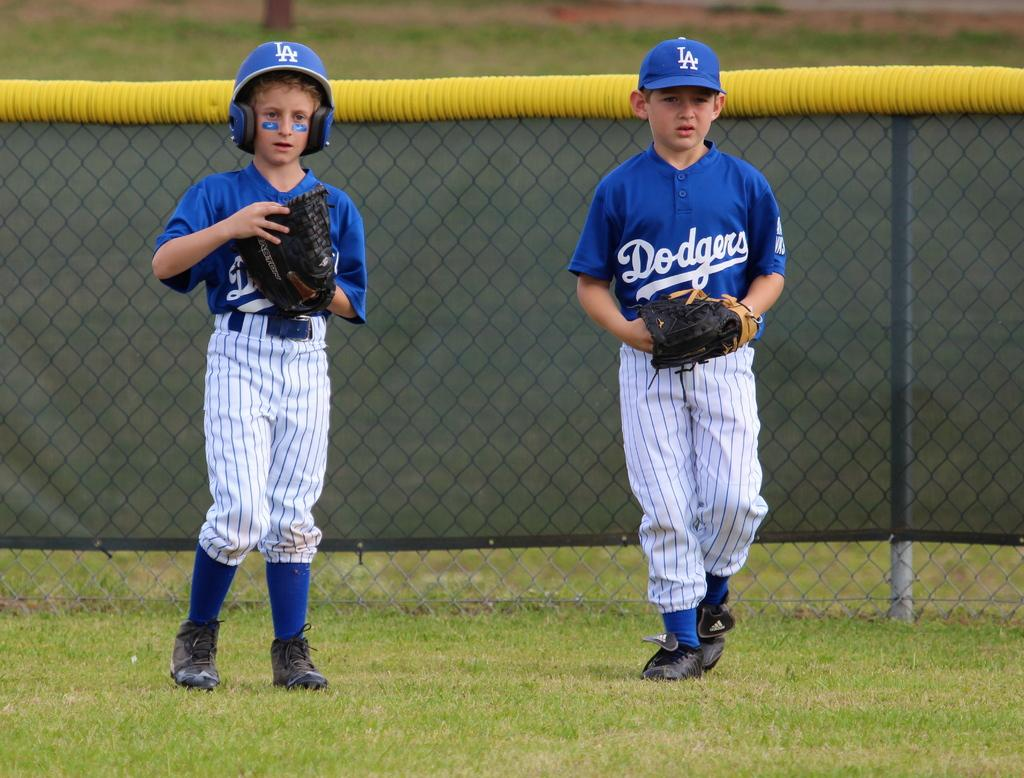<image>
Create a compact narrative representing the image presented. a little kid with a Dodgers outfit on 